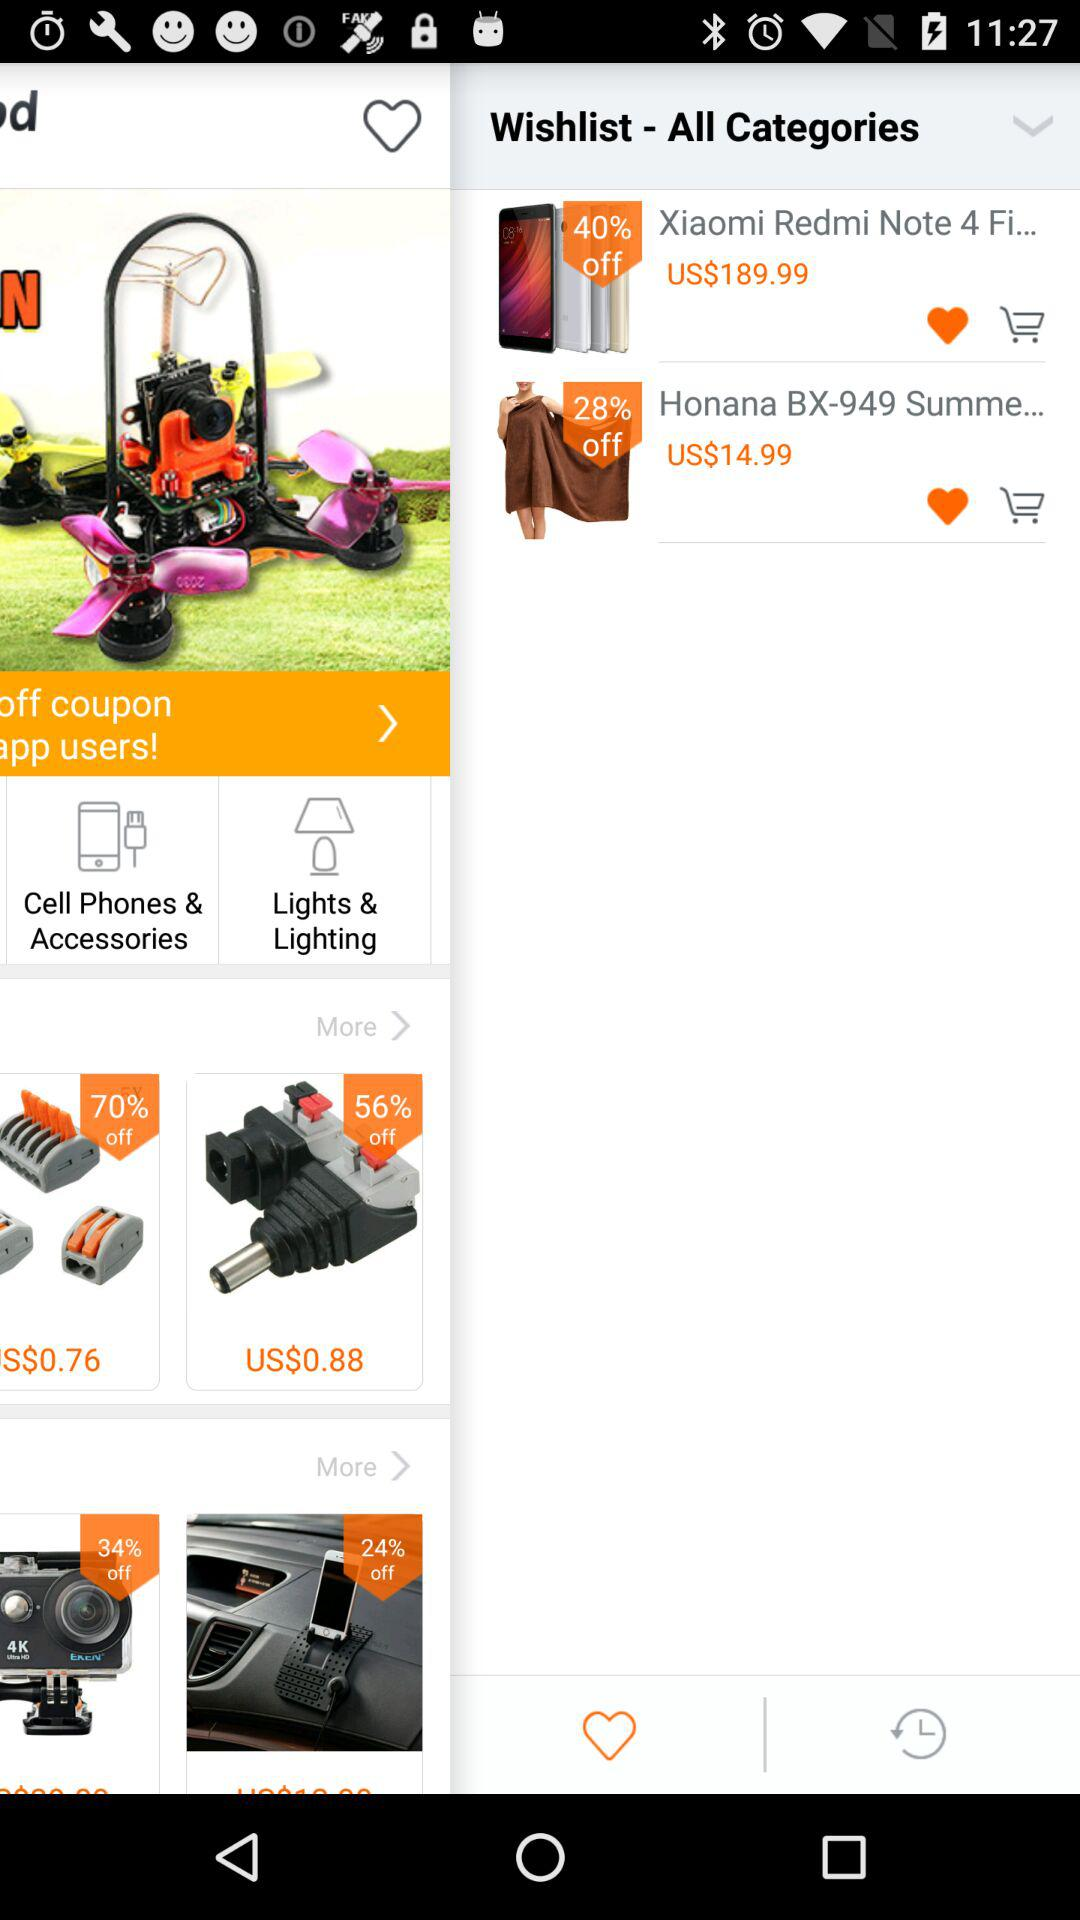How much of the amount is to be paid for "Honana BX-949"? The amount that is to be paid for "Honana BX-949" is US$14.99. 